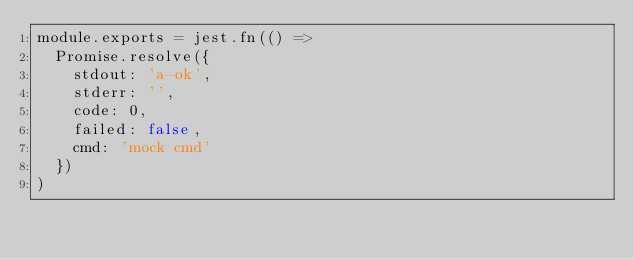Convert code to text. <code><loc_0><loc_0><loc_500><loc_500><_JavaScript_>module.exports = jest.fn(() =>
  Promise.resolve({
    stdout: 'a-ok',
    stderr: '',
    code: 0,
    failed: false,
    cmd: 'mock cmd'
  })
)
</code> 